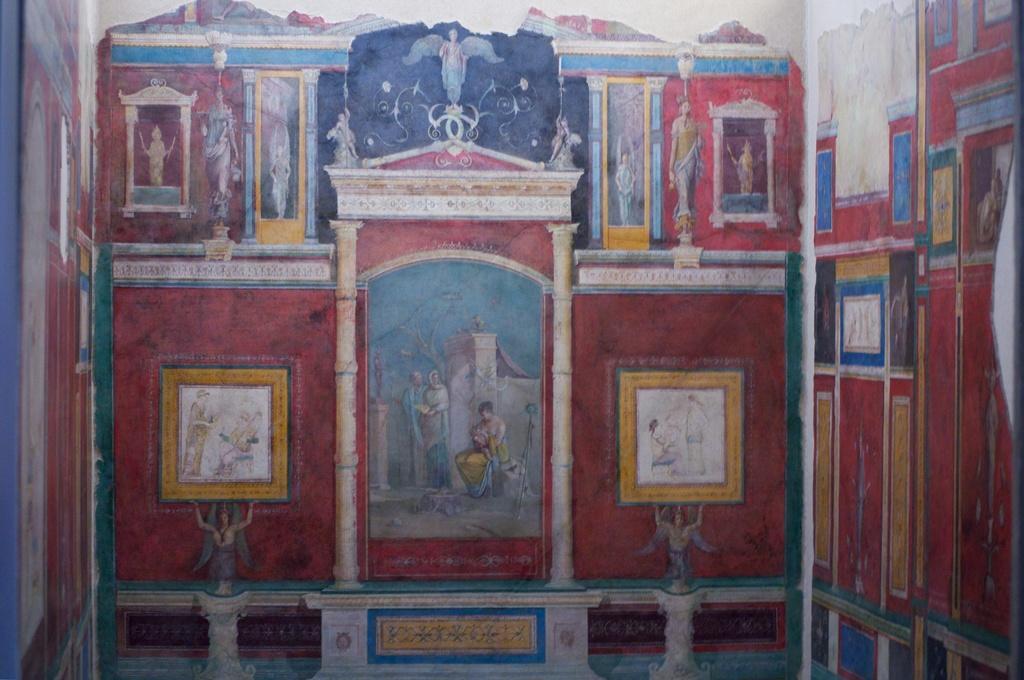How would you summarize this image in a sentence or two? In this image there is a wall and we can see a painting on the wall. In this painting there are people, buildings, statues and trees. 